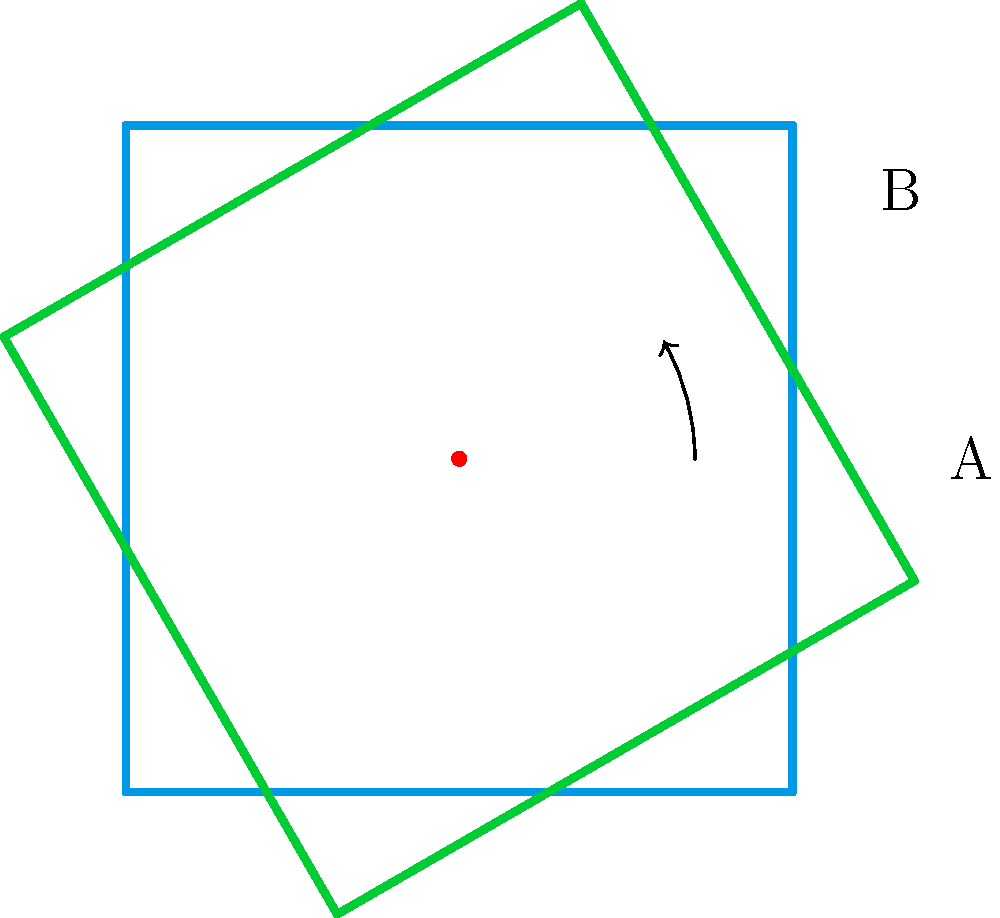In the Tiki Groupware user interface, you need to align two square widgets. The blue square represents the current position, and the green square shows the desired alignment. What is the angle of rotation needed to align the blue square with the green square? To find the angle of rotation needed to align the two squares, we can follow these steps:

1. Observe the given diagram: We have two squares, one blue (original position) and one green (desired position).

2. Identify the rotation: The rotation is counterclockwise from the blue square to the green square.

3. Locate the reference points: Point A is on the right side of the blue square, and point B is on the corresponding side of the green square.

4. Analyze the arc: There's an arc with an arrow showing the rotation from point A to point B.

5. Determine the angle: The angle between these two points represents the required rotation. In this case, it's clearly labeled as 30°.

Therefore, the angle of rotation needed to align the blue square with the green square is 30°.
Answer: 30° 